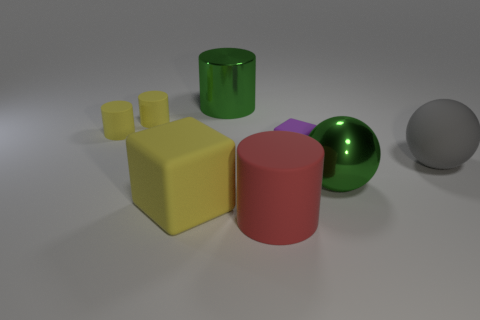What is the material of the large object that is the same color as the shiny ball?
Keep it short and to the point. Metal. What number of other objects are the same color as the big matte cube?
Make the answer very short. 2. Are the large yellow cube and the large green thing to the left of the red cylinder made of the same material?
Provide a short and direct response. No. What is the size of the yellow cube that is the same material as the big gray ball?
Offer a terse response. Large. Is there a gray thing that has the same shape as the large red matte thing?
Ensure brevity in your answer.  No. How many things are either things that are in front of the green metallic cylinder or big rubber cylinders?
Ensure brevity in your answer.  7. What size is the thing that is the same color as the large metal ball?
Offer a terse response. Large. There is a metallic object on the left side of the green shiny sphere; does it have the same color as the object in front of the large rubber cube?
Provide a short and direct response. No. The gray object has what size?
Your answer should be very brief. Large. What number of small objects are brown shiny cylinders or green balls?
Your answer should be compact. 0. 